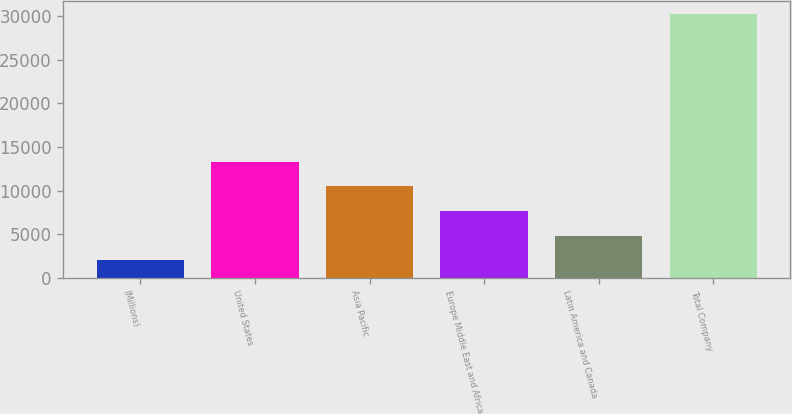Convert chart to OTSL. <chart><loc_0><loc_0><loc_500><loc_500><bar_chart><fcel>(Millions)<fcel>United States<fcel>Asia Pacific<fcel>Europe Middle East and Africa<fcel>Latin America and Canada<fcel>Total Company<nl><fcel>2015<fcel>13318.6<fcel>10492.7<fcel>7666.8<fcel>4840.9<fcel>30274<nl></chart> 